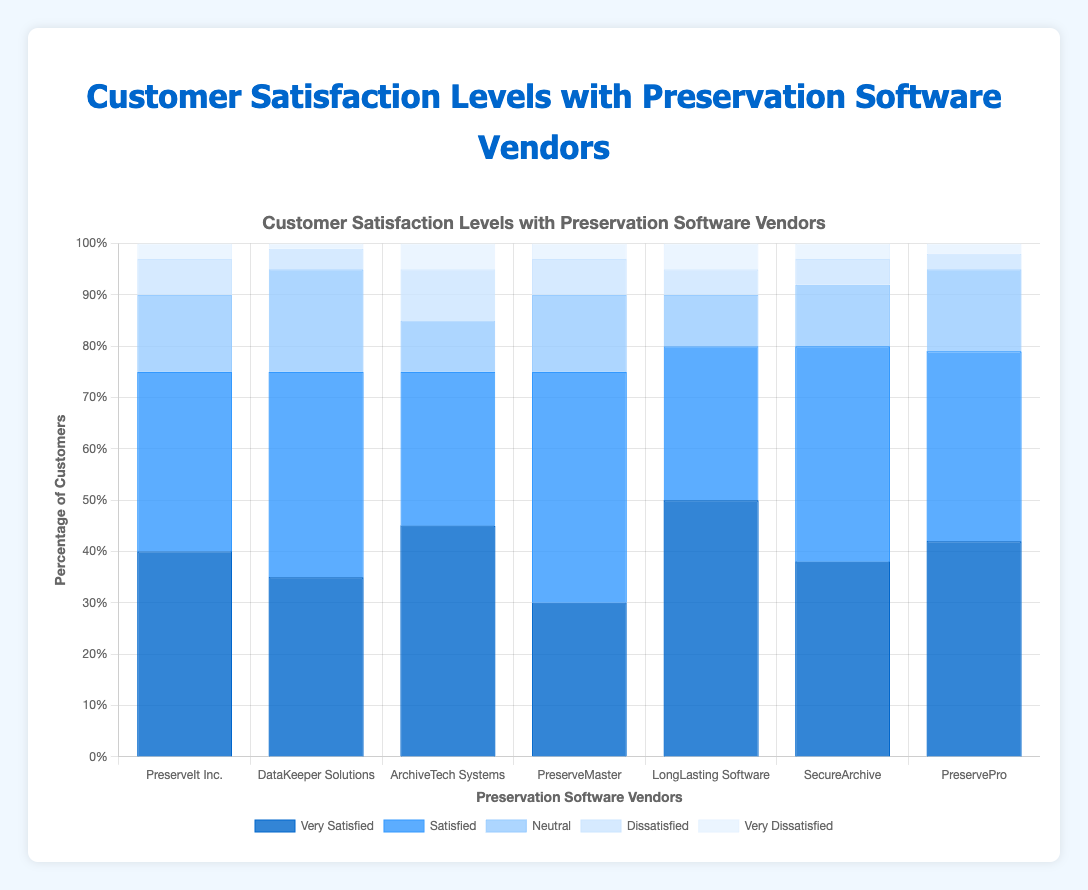What is the total percentage of customers that are very satisfied with PreserveIt Inc. and PreservePro? To find the total percentage, we add the 'very satisfied' percentages for PreserveIt Inc. (40%) and PreservePro (42%). This is 40% + 42% = 82%.
Answer: 82% Which vendor has the highest percentage of 'neutral' customers? We compare the 'neutral' percentages across all vendors: PreserveIt Inc. (15%), DataKeeper Solutions (20%), ArchiveTech Systems (10%), PreserveMaster (15%), LongLasting Software (10%), SecureArchive (12%), and PreservePro (16%). DataKeeper Solutions has the highest 'neutral' percentage with 20%.
Answer: DataKeeper Solutions Among all vendors, which one has the lowest percentage of 'very satisfied' customers? We check the 'very satisfied' percentages for each vendor: PreserveIt Inc. (40%), DataKeeper Solutions (35%), ArchiveTech Systems (45%), PreserveMaster (30%), LongLasting Software (50%), SecureArchive (38%), and PreservePro (42%). PreserveMaster has the lowest at 30%.
Answer: PreserveMaster What is the difference in 'dissatisfied' percentages between ArchiveTech Systems and DataKeeper Solutions? ArchiveTech Systems has 10% 'dissatisfied' customers and DataKeeper Solutions has 4%. The difference is 10% - 4% = 6%.
Answer: 6% How many vendors have a 'satisfied' percentage greater than 35%? We check if the 'satisfied' percentage is greater than 35% for each vendor: PreserveIt Inc. (35% - no), DataKeeper Solutions (40% - yes), ArchiveTech Systems (30% - no), PreserveMaster (45% - yes), LongLasting Software (30% - no), SecureArchive (42% - yes), and PreservePro (37% - yes). Four vendors meet this condition.
Answer: 4 Which vendor has the highest combined percentage of 'very dissatisfied' and 'dissatisfied' customers? We add the 'very dissatisfied' and 'dissatisfied' percentages for each vendor: PreserveIt Inc. (3% + 7% = 10%), DataKeeper Solutions (1% + 4% = 5%), ArchiveTech Systems (5% + 10% = 15%), PreserveMaster (3% + 7% = 10%), LongLasting Software (5% + 5% = 10%), SecureArchive (3% + 5% = 8%), and PreservePro (2% + 3% = 5%). ArchiveTech Systems has the highest combined percentage at 15%.
Answer: ArchiveTech Systems What is the average level of 'very satisfied' customers across all vendors? We sum the 'very satisfied' percentages and divide by the number of vendors: (40% + 35% + 45% + 30% + 50% + 38% + 42%) / 7 = 280% / 7 = 40%.
Answer: 40% What is the overall satisfaction level (sum of 'very satisfied' and 'satisfied' percentages) of LongLasting Software? LongLasting Software has 50% 'very satisfied' and 30% 'satisfied' customers. The overall satisfaction level is 50% + 30% = 80%.
Answer: 80% Which vendor has the highest 'very satisfied' percentage, and what is that percentage? We find the 'very satisfied' percentages for each vendor: PreserveIt Inc. (40%), DataKeeper Solutions (35%), ArchiveTech Systems (45%), PreserveMaster (30%), LongLasting Software (50%), SecureArchive (38%), and PreservePro (42%). LongLasting Software has the highest at 50%.
Answer: LongLasting Software at 50% 